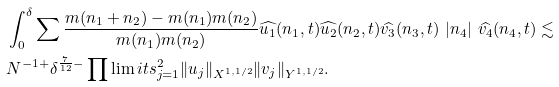<formula> <loc_0><loc_0><loc_500><loc_500>& \int _ { 0 } ^ { \delta } \sum \frac { m ( n _ { 1 } + n _ { 2 } ) - m ( n _ { 1 } ) m ( n _ { 2 } ) } { m ( n _ { 1 } ) m ( n _ { 2 } ) } \widehat { u _ { 1 } } ( n _ { 1 } , t ) \widehat { u _ { 2 } } ( n _ { 2 } , t ) \widehat { v _ { 3 } } ( n _ { 3 } , t ) \ | n _ { 4 } | \ \widehat { v _ { 4 } } ( n _ { 4 } , t ) \lesssim \\ & N ^ { - 1 + } \delta ^ { \frac { 7 } { 1 2 } - } \prod \lim i t s _ { j = 1 } ^ { 2 } \| u _ { j } \| _ { X ^ { 1 , 1 / 2 } } \| v _ { j } \| _ { Y ^ { 1 , 1 / 2 } } .</formula> 